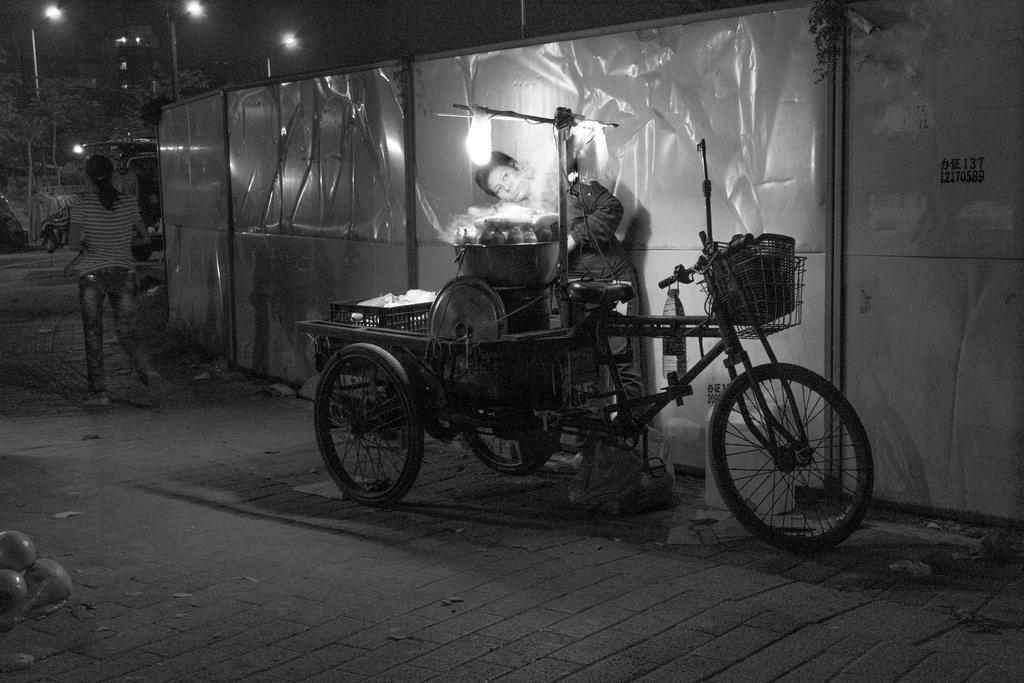How would you summarize this image in a sentence or two? In this image we can see a black and white picture of two persons standing on the ground, a cart with vessels, containers and baskets and a bottle placed on the ground. In the foreground we can see some objects placed on the ground. In the background, we can see a wall, light on stand, a group of light poles, trees, building and the sky. 